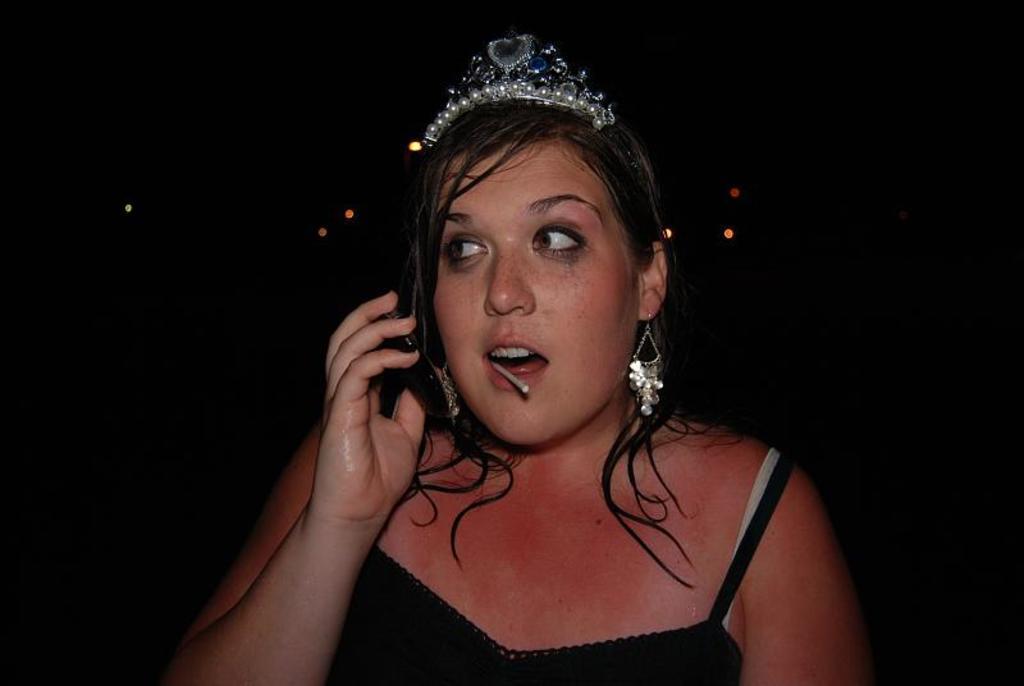Please provide a concise description of this image. In this image I can see a woman wearing black color dress and a crown. Background is in black color. 